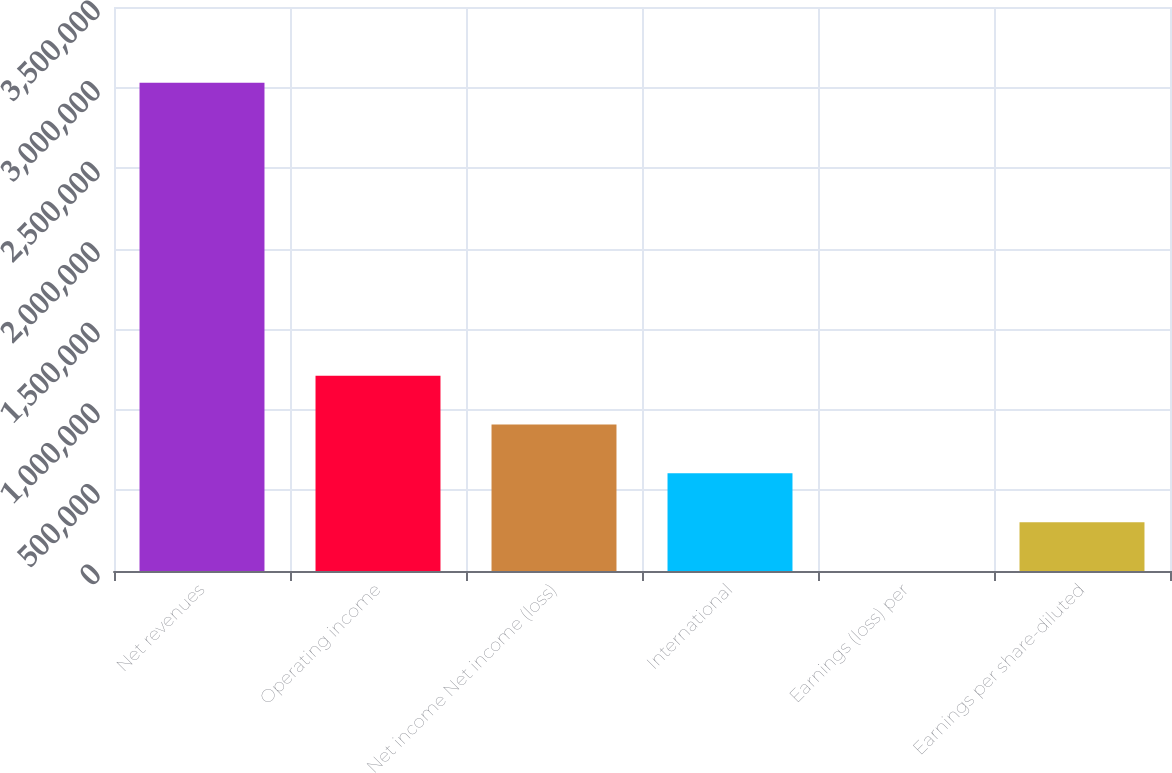Convert chart. <chart><loc_0><loc_0><loc_500><loc_500><bar_chart><fcel>Net revenues<fcel>Operating income<fcel>Net income Net income (loss)<fcel>International<fcel>Earnings (loss) per<fcel>Earnings per share-diluted<nl><fcel>3.0293e+06<fcel>1.21172e+06<fcel>908791<fcel>605861<fcel>0.26<fcel>302930<nl></chart> 